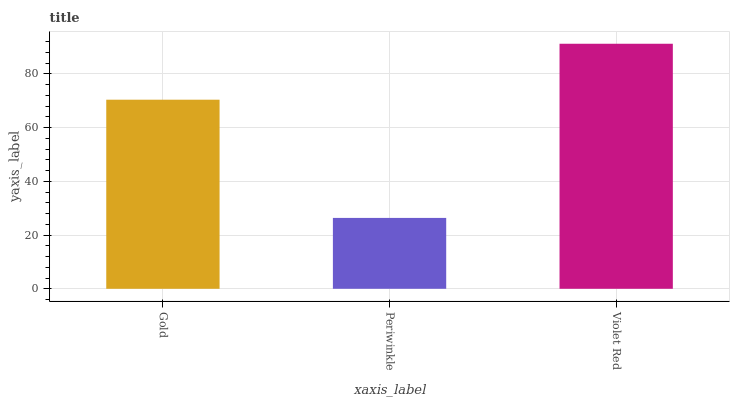Is Periwinkle the minimum?
Answer yes or no. Yes. Is Violet Red the maximum?
Answer yes or no. Yes. Is Violet Red the minimum?
Answer yes or no. No. Is Periwinkle the maximum?
Answer yes or no. No. Is Violet Red greater than Periwinkle?
Answer yes or no. Yes. Is Periwinkle less than Violet Red?
Answer yes or no. Yes. Is Periwinkle greater than Violet Red?
Answer yes or no. No. Is Violet Red less than Periwinkle?
Answer yes or no. No. Is Gold the high median?
Answer yes or no. Yes. Is Gold the low median?
Answer yes or no. Yes. Is Violet Red the high median?
Answer yes or no. No. Is Periwinkle the low median?
Answer yes or no. No. 